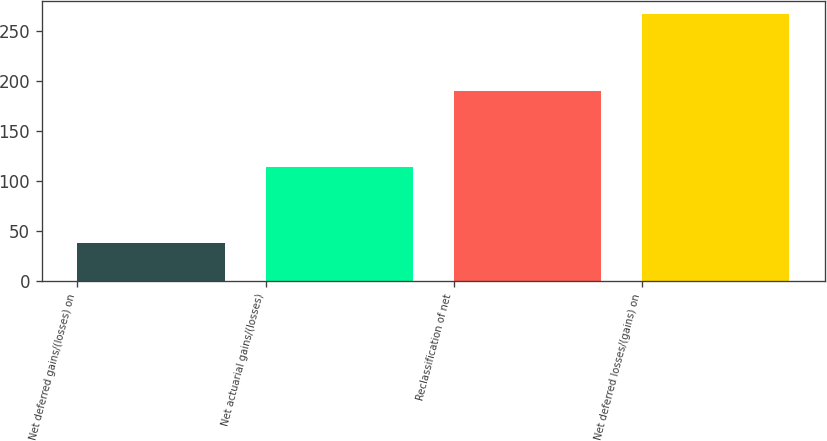Convert chart. <chart><loc_0><loc_0><loc_500><loc_500><bar_chart><fcel>Net deferred gains/(losses) on<fcel>Net actuarial gains/(losses)<fcel>Reclassification of net<fcel>Net deferred losses/(gains) on<nl><fcel>38<fcel>114.3<fcel>190.6<fcel>266.9<nl></chart> 